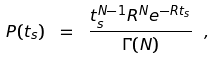<formula> <loc_0><loc_0><loc_500><loc_500>P ( t _ { s } ) \ = \ \frac { t _ { s } ^ { N - 1 } R ^ { N } e ^ { - R t _ { s } } } { \Gamma ( N ) } \ ,</formula> 